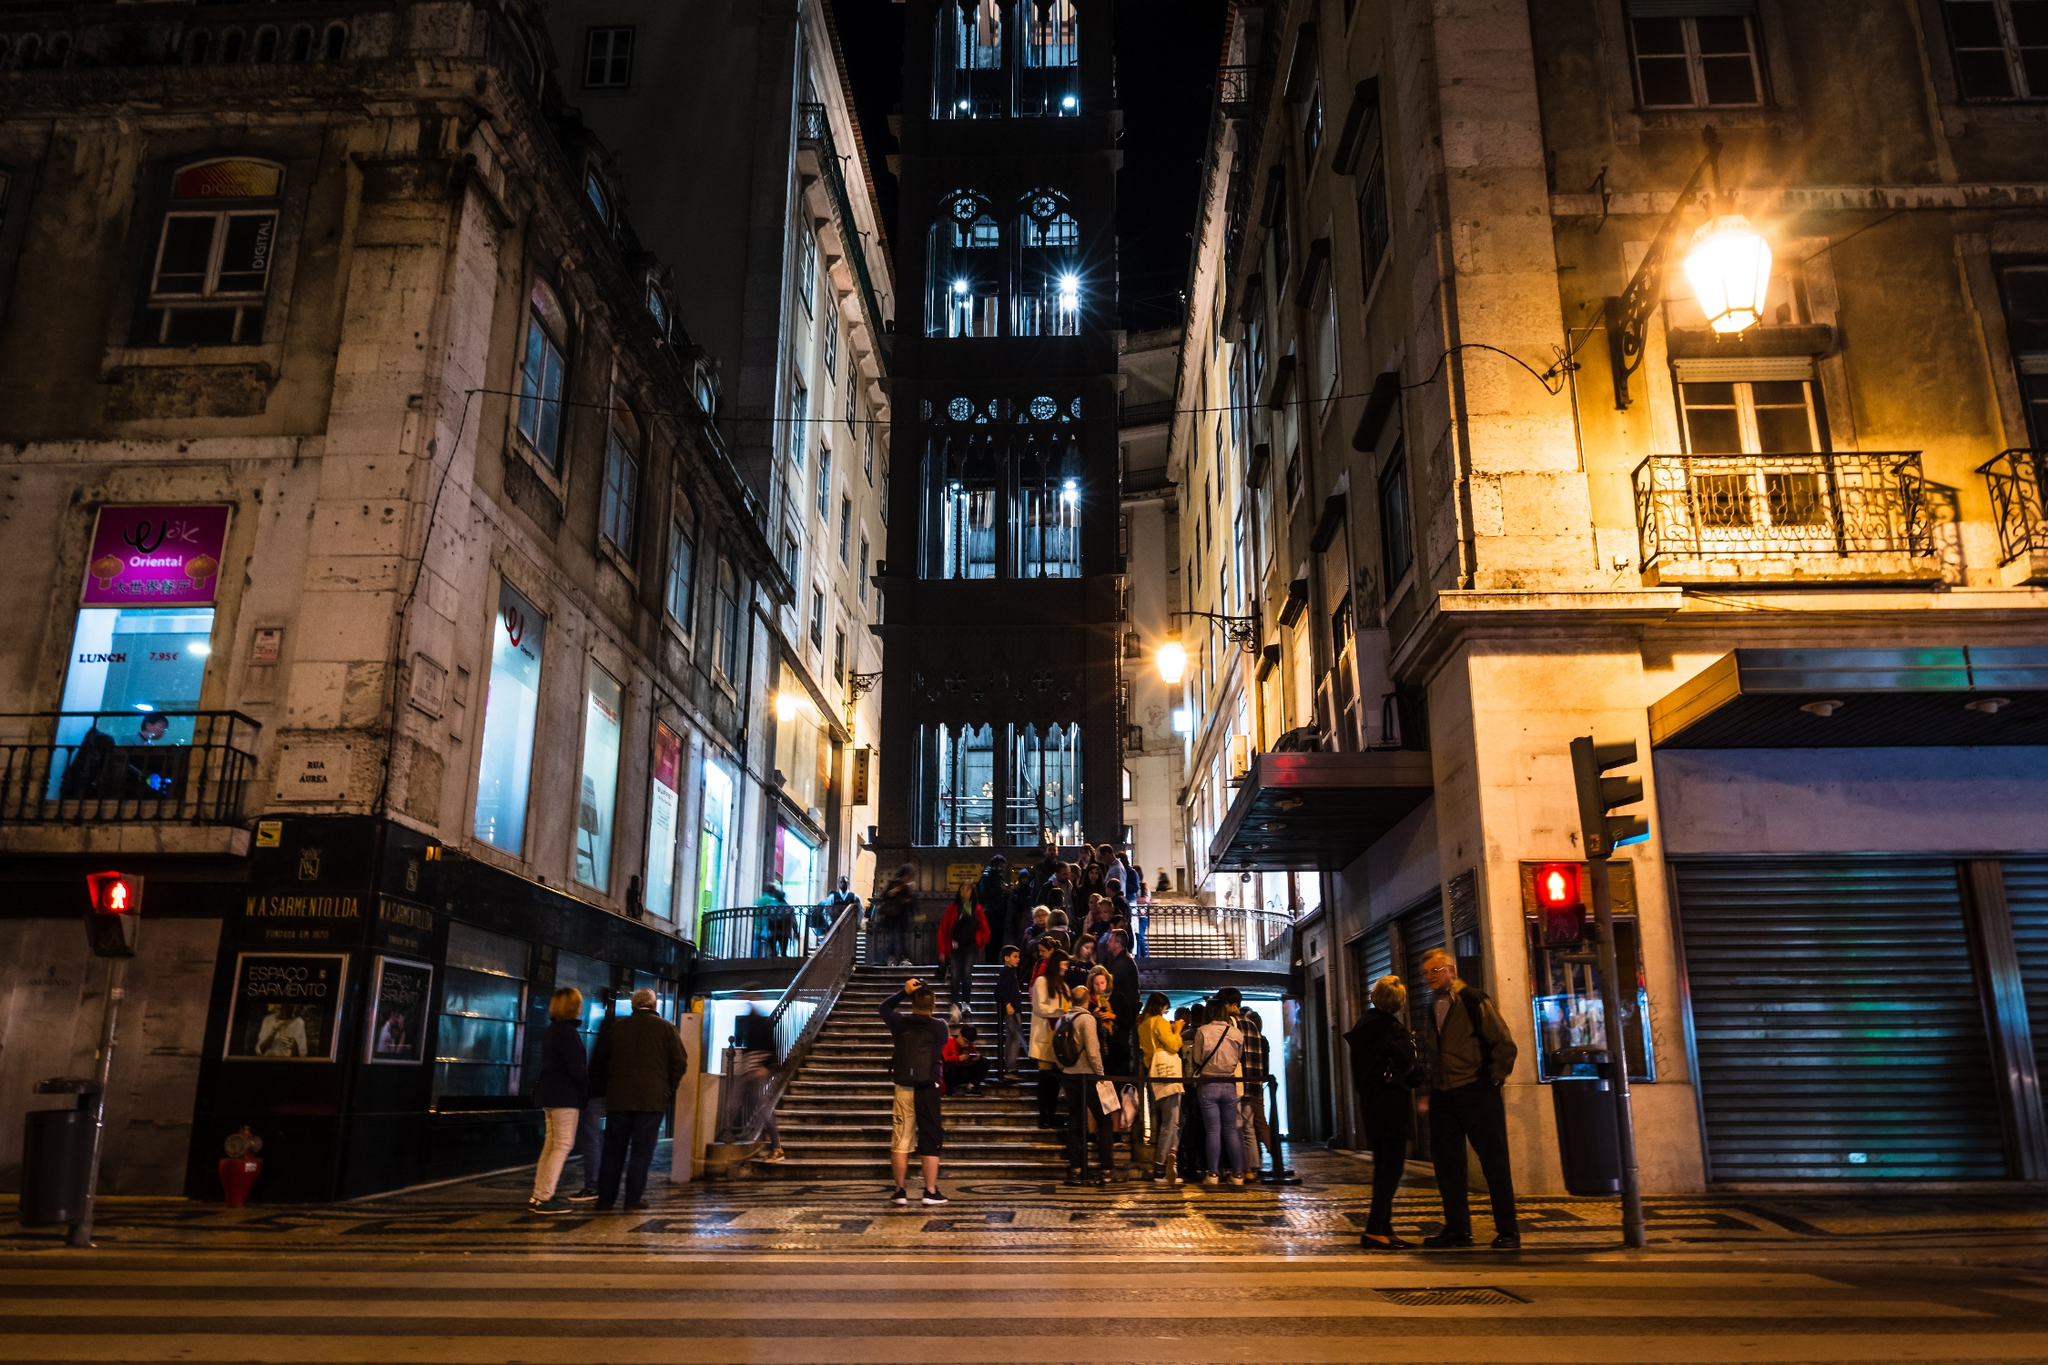What do you see happening in this image? The image captures the iconic Santa Justa Lift in Lisbon, Portugal, during nighttime. The lift is beautifully illuminated, casting a warm golden glow against the dark sky. The structure, which is tall and elegantly detailed, reflects its historical significance. At the base of the lift, a group of people can be seen gathered, waiting to use the elevator or simply admiring it, creating a lively atmosphere. The surrounding buildings, with their colorful storefronts and architectural styles, add vibrancy and context to the scene. The perspective of the photo emphasizes the height and prominence of the lift in the urban landscape. 